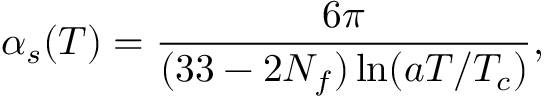<formula> <loc_0><loc_0><loc_500><loc_500>\alpha _ { s } ( T ) = { \frac { 6 \pi } { ( 3 3 - 2 N _ { f } ) \ln ( a T / T _ { c } ) } } ,</formula> 